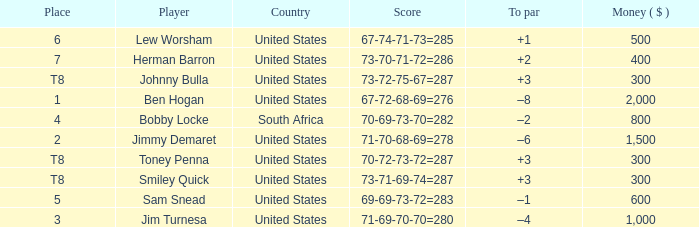What is the To par of the 4 Place Player? –2. 